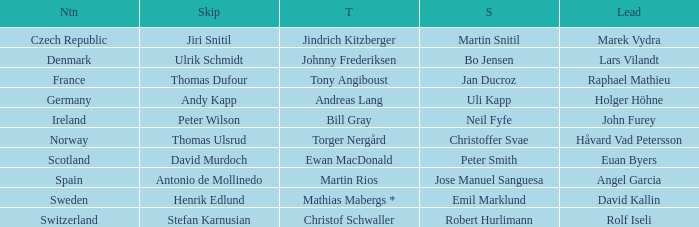When did holger höhne come in third? Andreas Lang. 